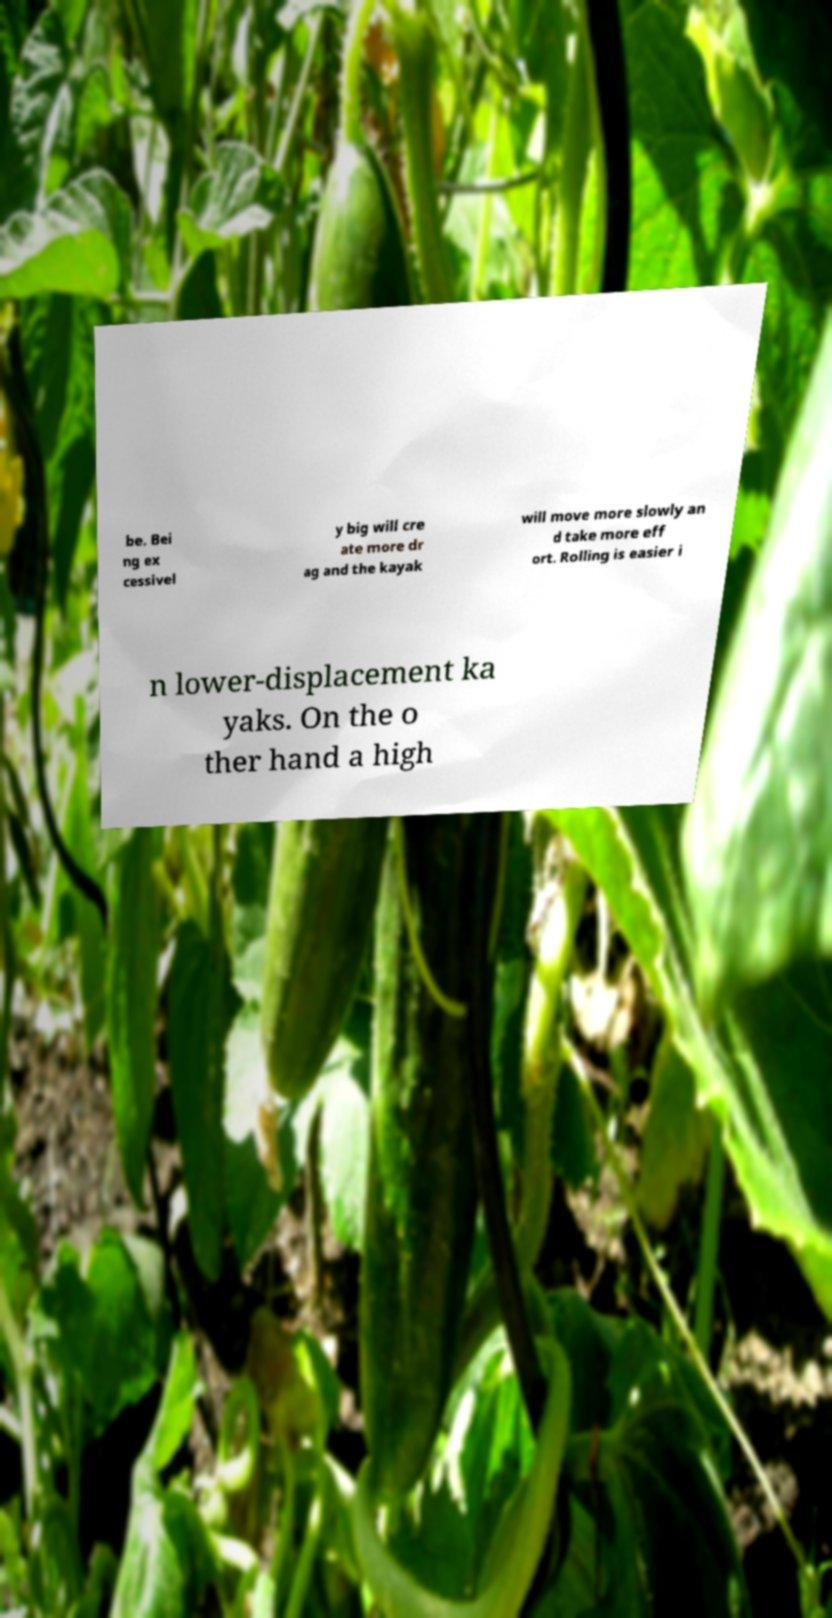What messages or text are displayed in this image? I need them in a readable, typed format. be. Bei ng ex cessivel y big will cre ate more dr ag and the kayak will move more slowly an d take more eff ort. Rolling is easier i n lower-displacement ka yaks. On the o ther hand a high 